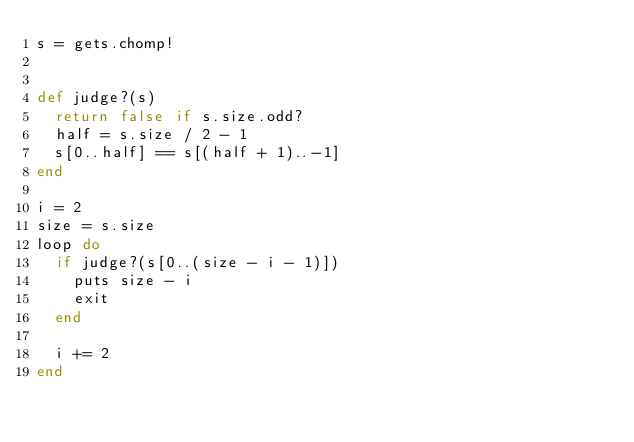<code> <loc_0><loc_0><loc_500><loc_500><_Ruby_>s = gets.chomp!


def judge?(s)
  return false if s.size.odd?
  half = s.size / 2 - 1
  s[0..half] == s[(half + 1)..-1]
end

i = 2
size = s.size
loop do
  if judge?(s[0..(size - i - 1)])
    puts size - i
    exit
  end

  i += 2
end
</code> 